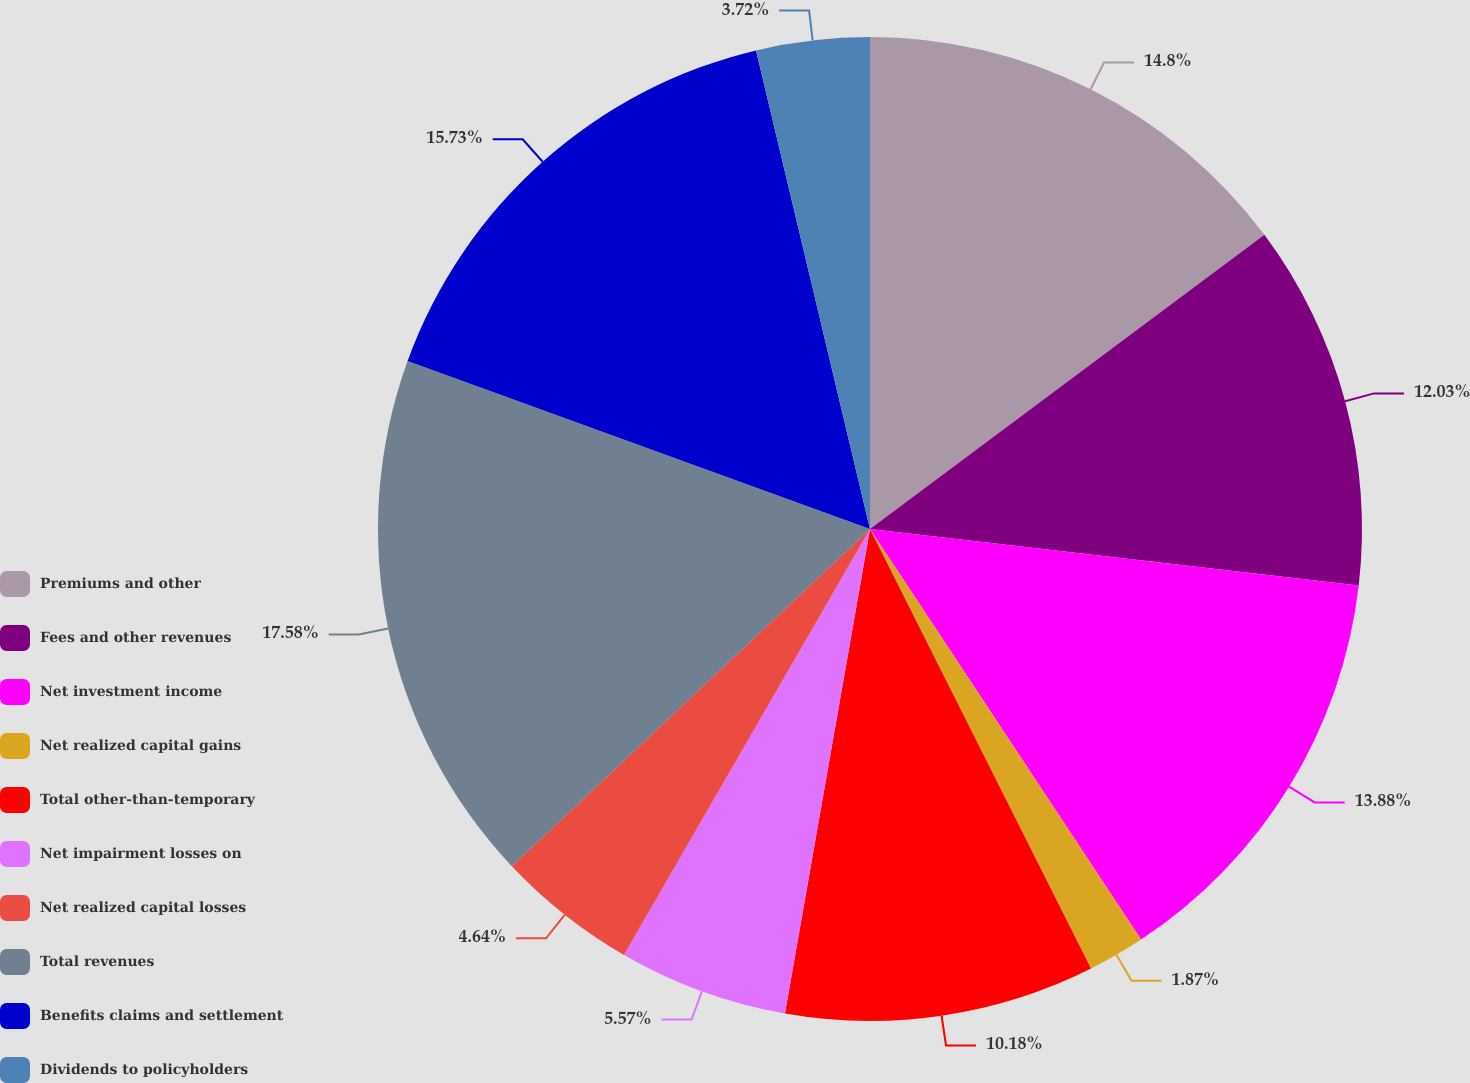Convert chart. <chart><loc_0><loc_0><loc_500><loc_500><pie_chart><fcel>Premiums and other<fcel>Fees and other revenues<fcel>Net investment income<fcel>Net realized capital gains<fcel>Total other-than-temporary<fcel>Net impairment losses on<fcel>Net realized capital losses<fcel>Total revenues<fcel>Benefits claims and settlement<fcel>Dividends to policyholders<nl><fcel>14.8%<fcel>12.03%<fcel>13.88%<fcel>1.87%<fcel>10.18%<fcel>5.57%<fcel>4.64%<fcel>17.57%<fcel>15.73%<fcel>3.72%<nl></chart> 